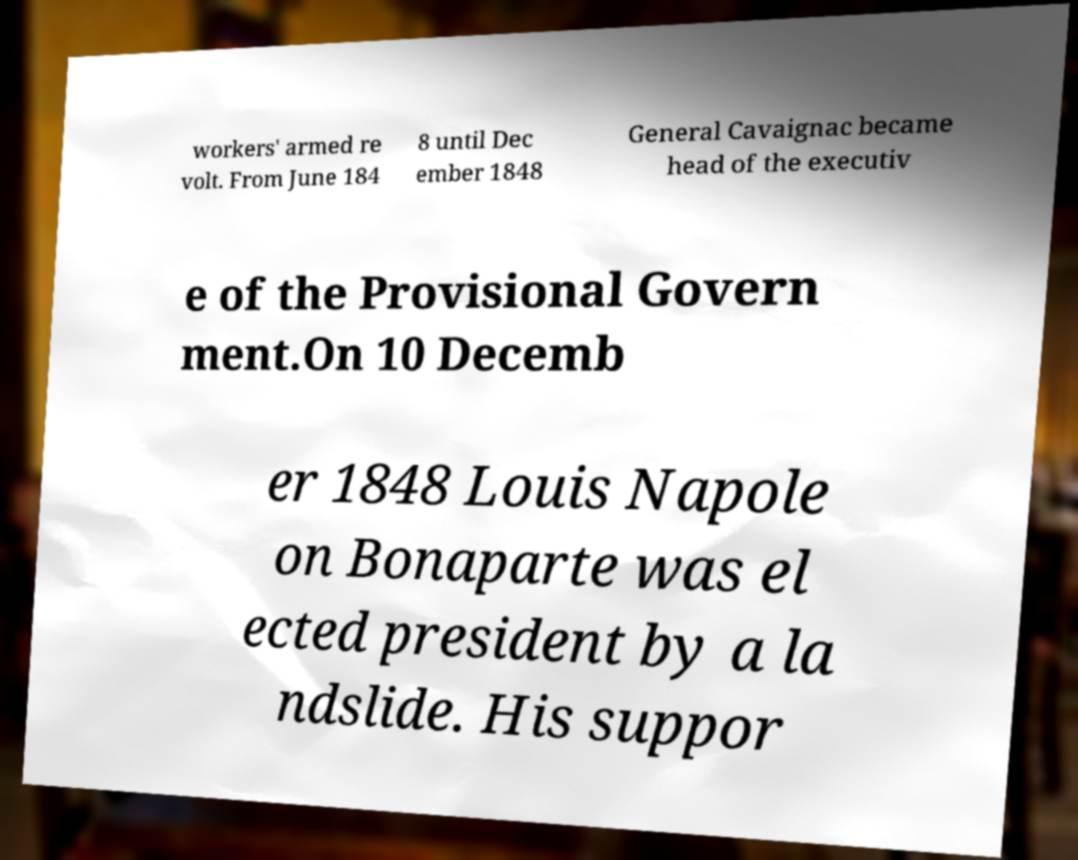Could you assist in decoding the text presented in this image and type it out clearly? workers' armed re volt. From June 184 8 until Dec ember 1848 General Cavaignac became head of the executiv e of the Provisional Govern ment.On 10 Decemb er 1848 Louis Napole on Bonaparte was el ected president by a la ndslide. His suppor 